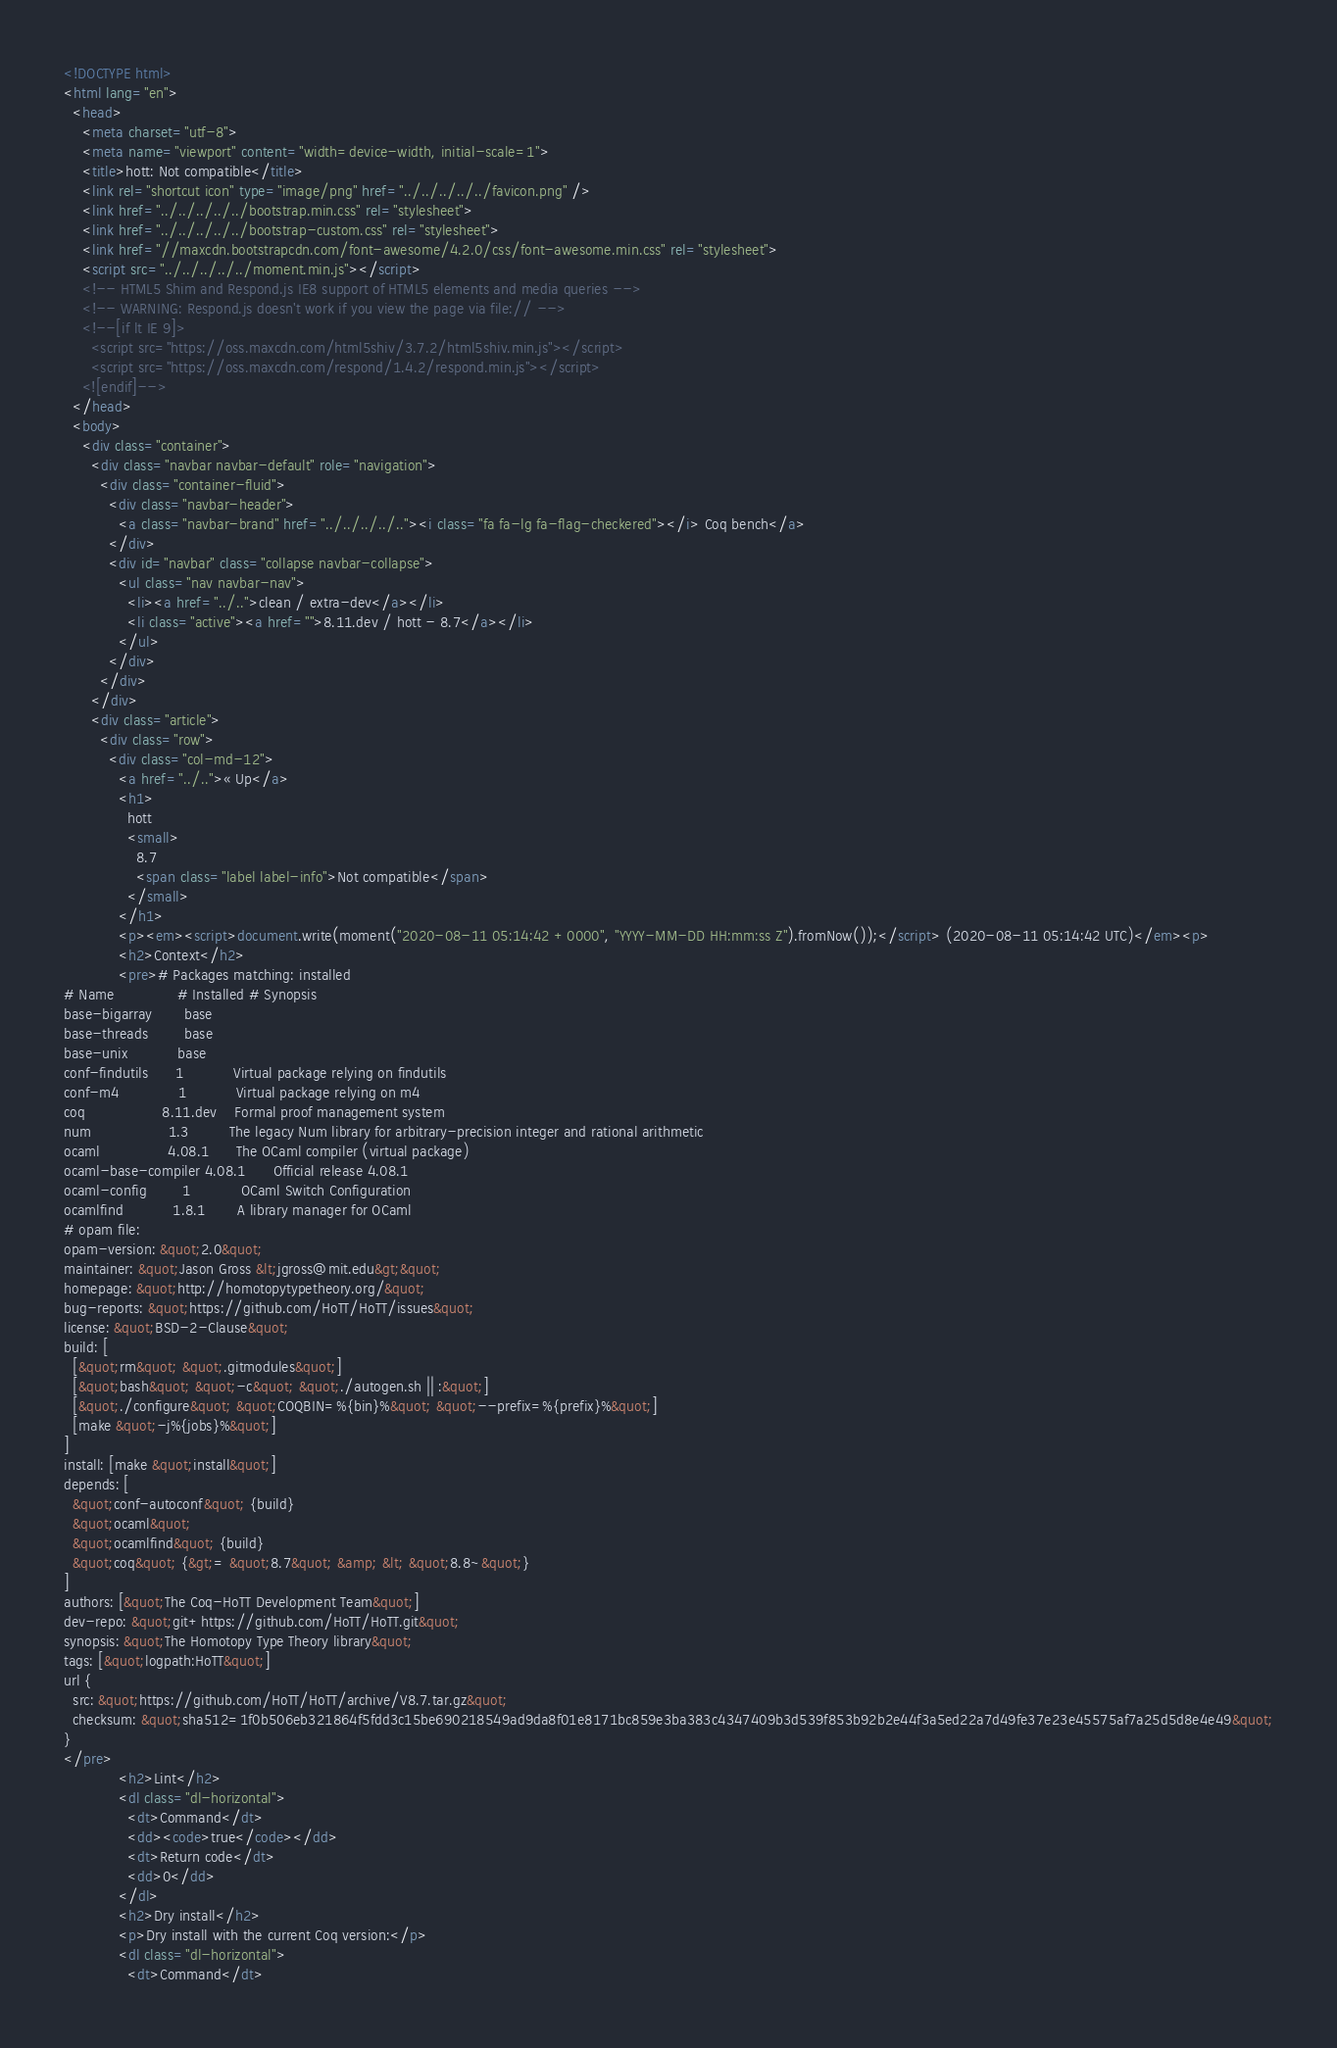<code> <loc_0><loc_0><loc_500><loc_500><_HTML_><!DOCTYPE html>
<html lang="en">
  <head>
    <meta charset="utf-8">
    <meta name="viewport" content="width=device-width, initial-scale=1">
    <title>hott: Not compatible</title>
    <link rel="shortcut icon" type="image/png" href="../../../../../favicon.png" />
    <link href="../../../../../bootstrap.min.css" rel="stylesheet">
    <link href="../../../../../bootstrap-custom.css" rel="stylesheet">
    <link href="//maxcdn.bootstrapcdn.com/font-awesome/4.2.0/css/font-awesome.min.css" rel="stylesheet">
    <script src="../../../../../moment.min.js"></script>
    <!-- HTML5 Shim and Respond.js IE8 support of HTML5 elements and media queries -->
    <!-- WARNING: Respond.js doesn't work if you view the page via file:// -->
    <!--[if lt IE 9]>
      <script src="https://oss.maxcdn.com/html5shiv/3.7.2/html5shiv.min.js"></script>
      <script src="https://oss.maxcdn.com/respond/1.4.2/respond.min.js"></script>
    <![endif]-->
  </head>
  <body>
    <div class="container">
      <div class="navbar navbar-default" role="navigation">
        <div class="container-fluid">
          <div class="navbar-header">
            <a class="navbar-brand" href="../../../../.."><i class="fa fa-lg fa-flag-checkered"></i> Coq bench</a>
          </div>
          <div id="navbar" class="collapse navbar-collapse">
            <ul class="nav navbar-nav">
              <li><a href="../..">clean / extra-dev</a></li>
              <li class="active"><a href="">8.11.dev / hott - 8.7</a></li>
            </ul>
          </div>
        </div>
      </div>
      <div class="article">
        <div class="row">
          <div class="col-md-12">
            <a href="../..">« Up</a>
            <h1>
              hott
              <small>
                8.7
                <span class="label label-info">Not compatible</span>
              </small>
            </h1>
            <p><em><script>document.write(moment("2020-08-11 05:14:42 +0000", "YYYY-MM-DD HH:mm:ss Z").fromNow());</script> (2020-08-11 05:14:42 UTC)</em><p>
            <h2>Context</h2>
            <pre># Packages matching: installed
# Name              # Installed # Synopsis
base-bigarray       base
base-threads        base
base-unix           base
conf-findutils      1           Virtual package relying on findutils
conf-m4             1           Virtual package relying on m4
coq                 8.11.dev    Formal proof management system
num                 1.3         The legacy Num library for arbitrary-precision integer and rational arithmetic
ocaml               4.08.1      The OCaml compiler (virtual package)
ocaml-base-compiler 4.08.1      Official release 4.08.1
ocaml-config        1           OCaml Switch Configuration
ocamlfind           1.8.1       A library manager for OCaml
# opam file:
opam-version: &quot;2.0&quot;
maintainer: &quot;Jason Gross &lt;jgross@mit.edu&gt;&quot;
homepage: &quot;http://homotopytypetheory.org/&quot;
bug-reports: &quot;https://github.com/HoTT/HoTT/issues&quot;
license: &quot;BSD-2-Clause&quot;
build: [
  [&quot;rm&quot; &quot;.gitmodules&quot;]
  [&quot;bash&quot; &quot;-c&quot; &quot;./autogen.sh || :&quot;]
  [&quot;./configure&quot; &quot;COQBIN=%{bin}%&quot; &quot;--prefix=%{prefix}%&quot;]
  [make &quot;-j%{jobs}%&quot;]
]
install: [make &quot;install&quot;]
depends: [
  &quot;conf-autoconf&quot; {build}
  &quot;ocaml&quot;
  &quot;ocamlfind&quot; {build}
  &quot;coq&quot; {&gt;= &quot;8.7&quot; &amp; &lt; &quot;8.8~&quot;}
]
authors: [&quot;The Coq-HoTT Development Team&quot;]
dev-repo: &quot;git+https://github.com/HoTT/HoTT.git&quot;
synopsis: &quot;The Homotopy Type Theory library&quot;
tags: [&quot;logpath:HoTT&quot;]
url {
  src: &quot;https://github.com/HoTT/HoTT/archive/V8.7.tar.gz&quot;
  checksum: &quot;sha512=1f0b506eb321864f5fdd3c15be690218549ad9da8f01e8171bc859e3ba383c4347409b3d539f853b92b2e44f3a5ed22a7d49fe37e23e45575af7a25d5d8e4e49&quot;
}
</pre>
            <h2>Lint</h2>
            <dl class="dl-horizontal">
              <dt>Command</dt>
              <dd><code>true</code></dd>
              <dt>Return code</dt>
              <dd>0</dd>
            </dl>
            <h2>Dry install</h2>
            <p>Dry install with the current Coq version:</p>
            <dl class="dl-horizontal">
              <dt>Command</dt></code> 